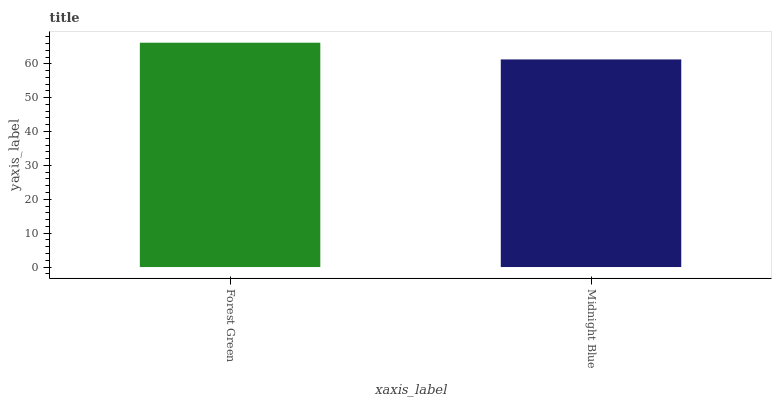Is Midnight Blue the minimum?
Answer yes or no. Yes. Is Forest Green the maximum?
Answer yes or no. Yes. Is Midnight Blue the maximum?
Answer yes or no. No. Is Forest Green greater than Midnight Blue?
Answer yes or no. Yes. Is Midnight Blue less than Forest Green?
Answer yes or no. Yes. Is Midnight Blue greater than Forest Green?
Answer yes or no. No. Is Forest Green less than Midnight Blue?
Answer yes or no. No. Is Forest Green the high median?
Answer yes or no. Yes. Is Midnight Blue the low median?
Answer yes or no. Yes. Is Midnight Blue the high median?
Answer yes or no. No. Is Forest Green the low median?
Answer yes or no. No. 